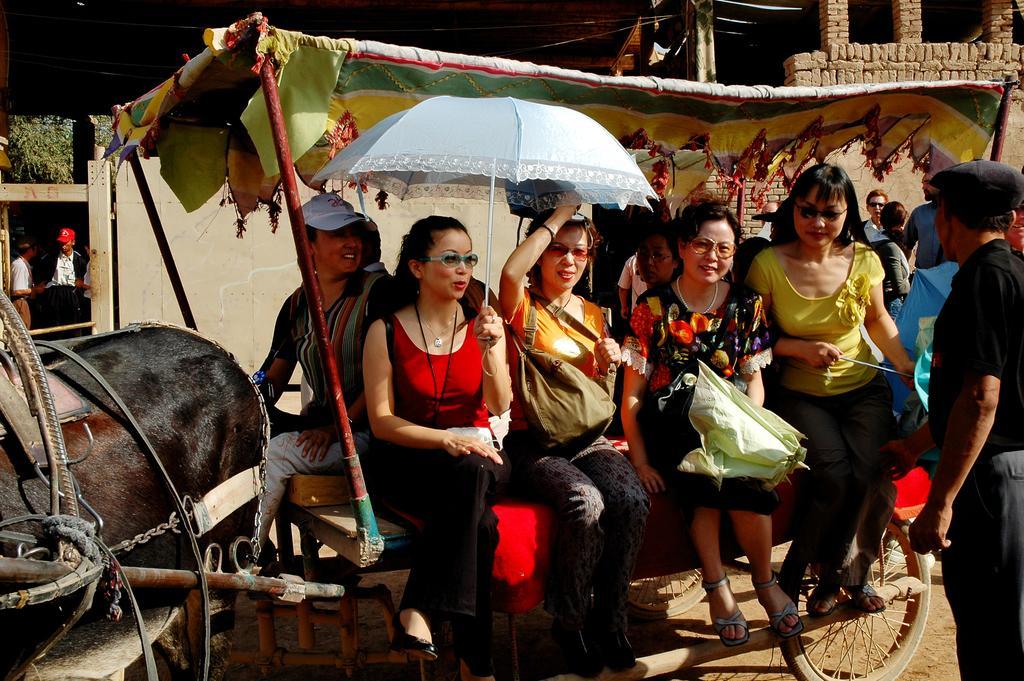How would you summarize this image in a sentence or two? On the left we can see horse. In the center we can see few persons were sitting on the cart and holding umbrella. On the right we can see one man standing. In the background there is a brick wall,tent,trees and few persons were standing. 